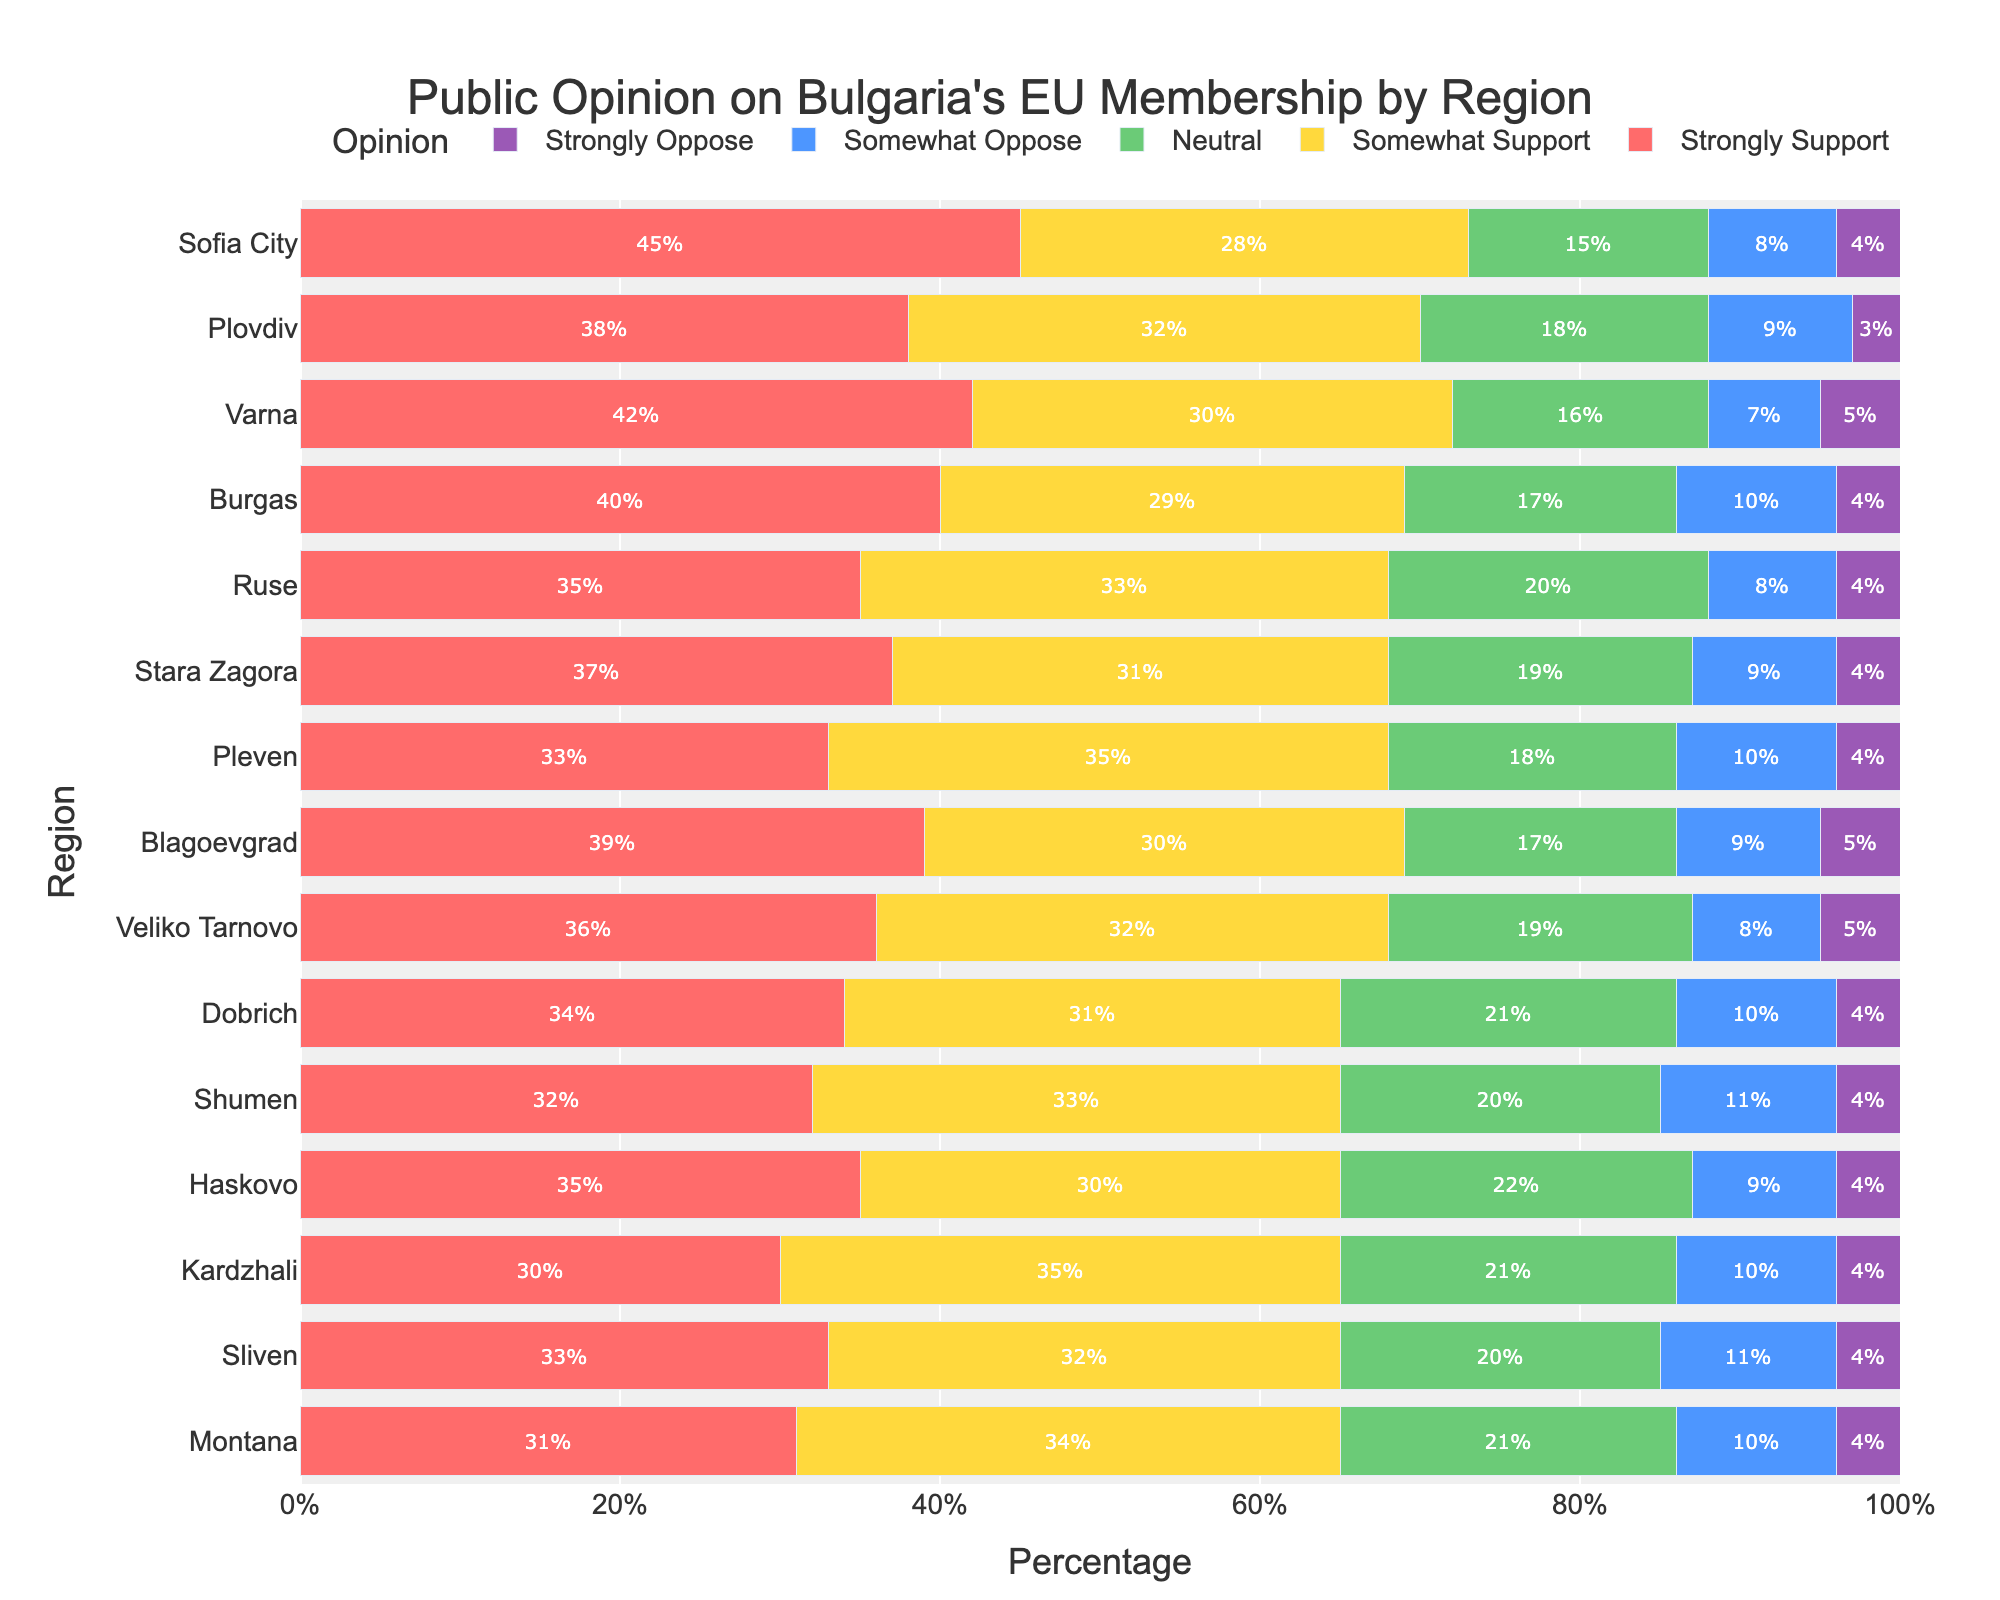Which region has the highest percentage of strong support for Bulgaria's EU membership? The bar representing Sofia City is the longest in the "Strongly Support" category, indicating it has the highest percentage.
Answer: Sofia City Which region shows the highest percentage of neutral opinion? From visually inspecting the neutral (yellow) bars, Haskovo has the longest bar.
Answer: Haskovo How do Varna and Ruse compare in terms of strong opposition to EU membership? Comparing the lengths of the purple (strongly oppose) bars for Varna and Ruse, both seem equal, indicating equal percentage.
Answer: Equal What is the combined percentage of somewhat support and strong support in Plovdiv? Sum the percentages for "Somewhat Support" and "Strongly Support" in Plovdiv (32 + 38).
Answer: 70% Which region has the lowest percentage of somewhat support? By comparing the lengths of the green bars, Sofia City has the shortest bar in the "Somewhat Support" category.
Answer: Sofia City In regions where the percentage of strong support is at least 35%, what is the average neutral percentage? Filter regions where "Strongly Support" is ≥ 35: Sofia City, Plovdiv, Varna, Burgas, Ruse, Stara Zagora, Blagoevgrad, Veliko Tarnovo, Dobrich, Haskovo, Sliven. Calculate the average of their "Neutral" percentages: (15 + 18 + 16 + 17 + 20 + 19 + 17 + 19 + 21 + 22 + 20) / 11.
Answer: 18.18% What can be said about the trend of opposition (somewhat and strong) across different regions? Observing the lengths of the blue and purple bars across all regions, no region shows a significant spike in opposition, illustrating general consistency in opposition percentages.
Answer: Consistent Which three regions have the highest summed percentage of somewhat support and neutral opinion? Calculate "Somewhat Support" + "Neutral" for each region and compare: Sofia City (28+15), Plovdiv (32+18), Varna (30+16), Burgas (29+17), Ruse (33+20), Stara Zagora (31+19), Pleven (35+18), Blagoevgrad (30+17), Veliko Tarnovo (32+19), Dobrich (31+21), Shumen (33+20), Haskovo (30+22), Kardzhali (35+21), Sliven (32+20), Montana (34+21). Top three sums are Kardzhali, Pleven, Ruse.
Answer: Kardzhali, Pleven, Ruse 